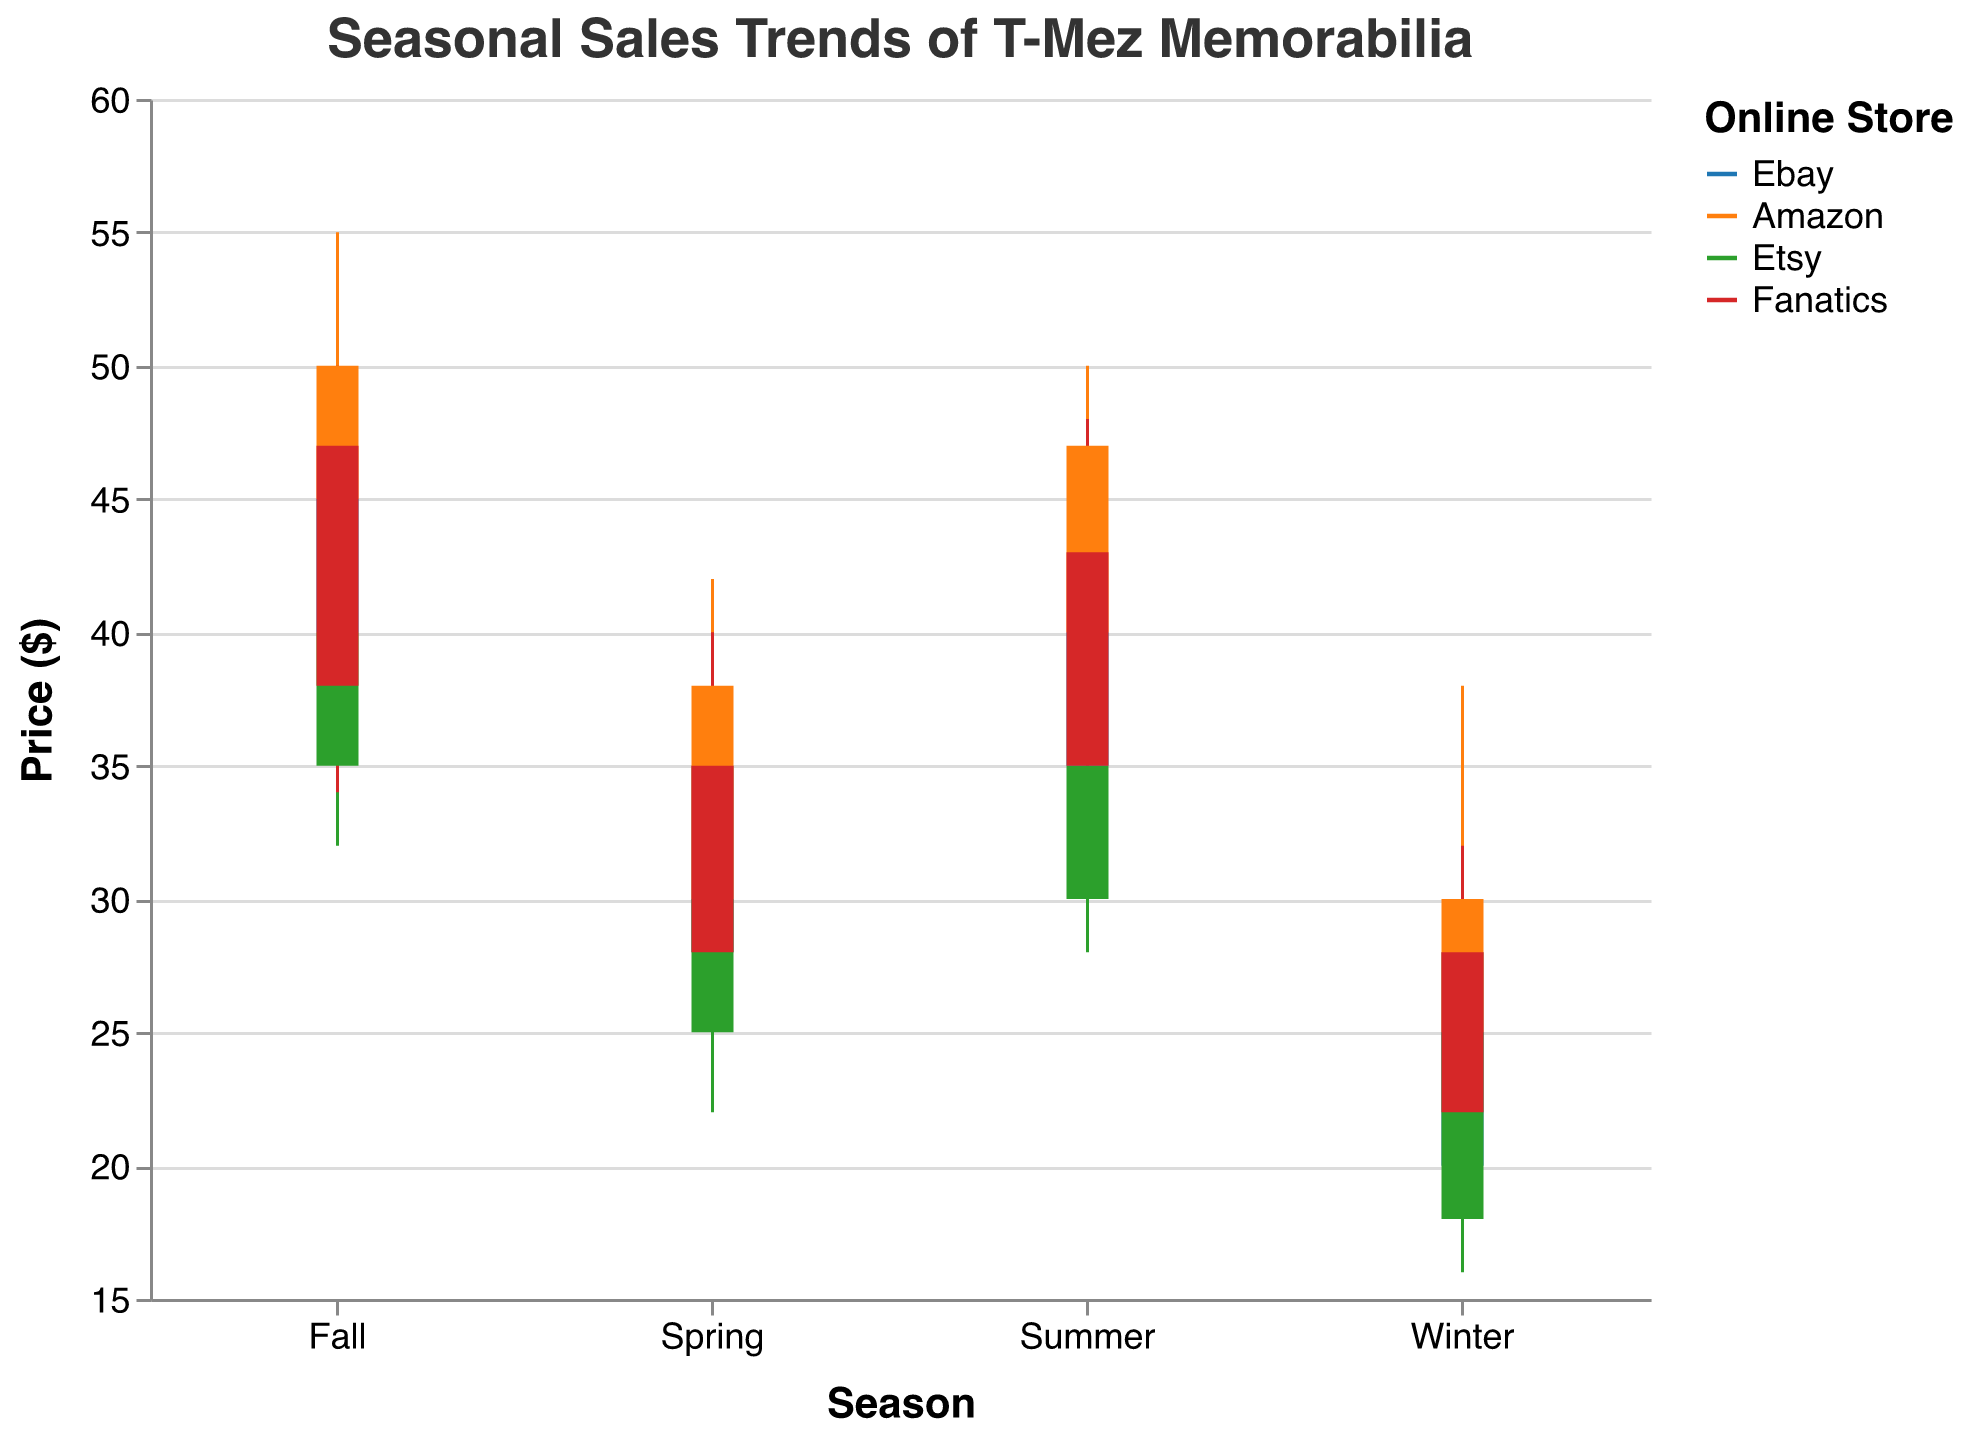What is the highest price recorded for T-Mez memorabilia in the Summer season on Amazon? In the Summer season for Amazon, the High price column shows the peak value. Referring to the candlestick plot, the highest price (High) for Amazon in Summer is 50.
Answer: 50 Which store showed the greatest increase in closing prices from Winter to Fall? To find the greatest increase, subtract the Winter closing price from the Fall closing price for each store. For Ebay, the increase is 45 - 28 = 17. For Amazon, it's 50 - 30 = 20. For Etsy, it's 40 - 25 = 15. For Fanatics, it's 47 - 28 = 19. Amazon shows the greatest increase.
Answer: Amazon What is the median high price for T-Mez memorabilia across all seasons on Ebay? The high prices for Ebay are 35 (Winter), 40 (Spring), 45 (Summer), 50 (Fall). Arranging them in a numerical order, we get 35, 40, 45, 50. The median value is the average of the two middle numbers: (40 + 45) / 2 = 42.5.
Answer: 42.5 Which store has the least variability in the high prices across all seasons? To find the least variability, compare the range (High - Low) for each store's high prices across all seasons. For Ebay: 50 - 35 = 15. For Amazon: 55 - 38 = 17. For Etsy: 48 - 28 = 20. For Fanatics: 50 - 32 = 18. Ebay has the smallest range in high prices.
Answer: Ebay By how much did the closing price of T-Mez memorabilia increase from Spring to Summer on Etsy? The closing prices for Etsy are 30 (Spring) and 35 (Summer). The increase from Spring to Summer is 35 - 30 = 5.
Answer: 5 Which season recorded the lowest price for T-Mez memorabilia on Fanatics, and what was that price? Looking at the Low price column for Fanatics across all seasons, the lowest price is 20 in Winter.
Answer: Winter, 20 How does the closing price in Fall for Ebay compare to the high price in Spring for Etsy? The closing price for Ebay in Fall is 45, and the high price for Etsy in Spring is 38. Comparing these, 45 (Ebay Fall) is greater than 38 (Etsy Spring).
Answer: Greater What is the average opening price for T-Mez memorabilia on Amazon across all seasons? The opening prices for Amazon are 25 (Winter), 30 (Spring), 40 (Summer), 45 (Fall). The average is calculated by (25 + 30 + 40 + 45) / 4 = 35.
Answer: 35 Which store had the highest closing price in any season, and what was that price? Referring to the Close column for all stores and seasons, the highest closing price is 50 which occurred for Amazon in Fall.
Answer: Amazon, 50 